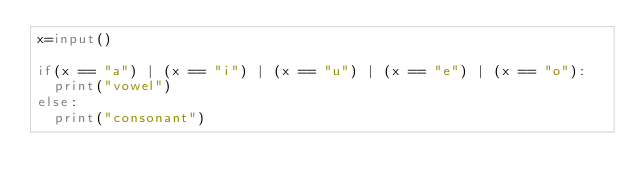Convert code to text. <code><loc_0><loc_0><loc_500><loc_500><_Python_>x=input()

if(x == "a") | (x == "i") | (x == "u") | (x == "e") | (x == "o"):
  print("vowel")
else:
  print("consonant")</code> 